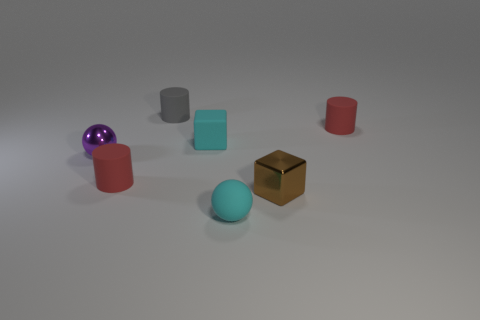Subtract all tiny red matte cylinders. How many cylinders are left? 1 Subtract all brown blocks. How many blocks are left? 1 Subtract 2 cubes. How many cubes are left? 0 Add 1 tiny cyan matte cylinders. How many objects exist? 8 Subtract all purple cubes. How many red cylinders are left? 2 Subtract all cylinders. How many objects are left? 4 Subtract 0 yellow blocks. How many objects are left? 7 Subtract all blue cylinders. Subtract all red blocks. How many cylinders are left? 3 Subtract all tiny metallic cylinders. Subtract all tiny gray cylinders. How many objects are left? 6 Add 1 small red cylinders. How many small red cylinders are left? 3 